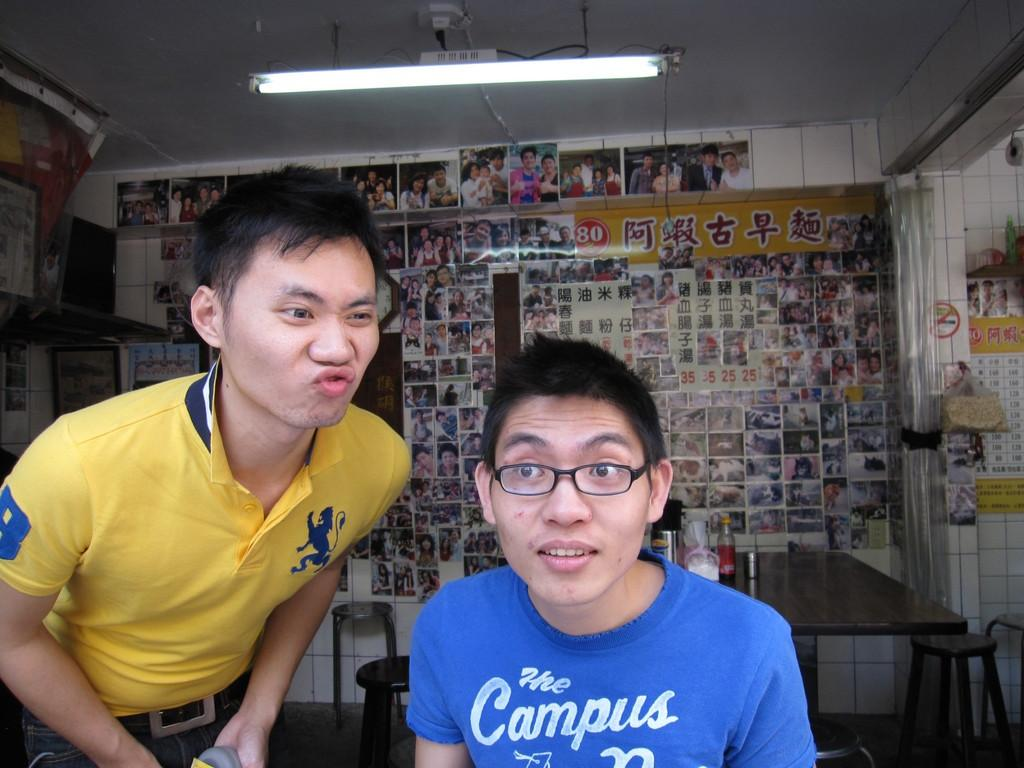How many people are present in the image? There are two persons in the image. What type of furniture can be seen in the image? There is a table and a chair in the image. What is visible in the background of the image? There are pictures on the wall in the background. What type of boat is visible in the image? There is no boat present in the image. On which channel can the conversation between the two persons be heard? The image is a still photograph, so there is no audio or channel to listen to a conversation. 